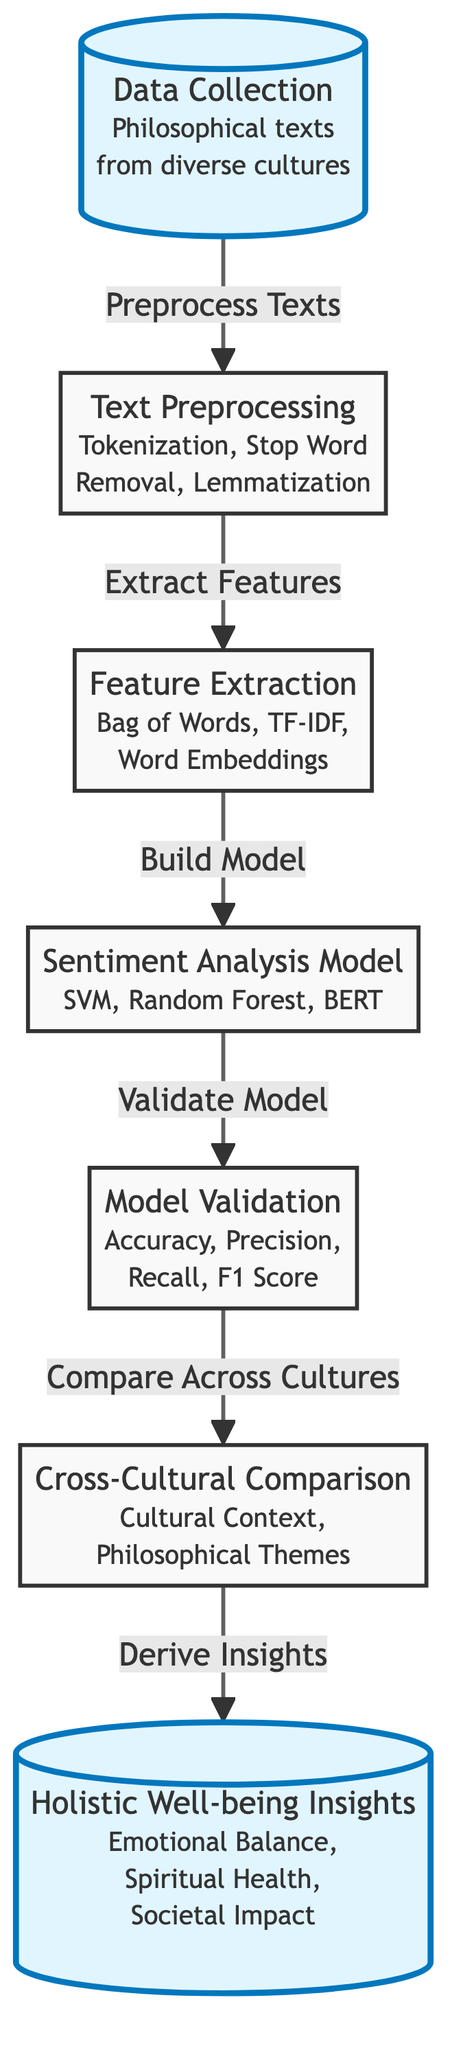What is the first step in the diagram? The diagram begins with the first step labeled "Data Collection" which involves collecting philosophical texts from diverse cultures.
Answer: Data Collection How many main process nodes are in the diagram? Counting the labeled nodes in the flowchart provides a total of seven main process nodes that represent key steps in the sentiment analysis framework.
Answer: Seven What type of models are mentioned for sentiment analysis? The sentiment analysis model section specifies several model types, including Support Vector Machine, Random Forest, and BERT.
Answer: SVM, Random Forest, BERT What is the output of the validation step? The validation step leads to the assessment of model quality using accuracy, precision, recall, and F1 score, indicating how effective the model is after it has been built.
Answer: Accuracy, Precision, Recall, F1 Score Which node describes deriving insights? The "Holistic Well-being Insights" node is where insights about emotional balance, spiritual health, and societal impact are derived from the analysis, representing the final goal of the process.
Answer: Holistic Well-being Insights In what step does feature extraction occur? The feature extraction occurs between the text preprocessing and model building steps, which specifically involves converting text data into formats usable by machine learning models.
Answer: Extract Features What is compared in the cross-cultural comparison step? This step involves a comparison that focuses on cultural context and philosophical themes, thereby evaluating how different cultures interpret messages in philosophical texts.
Answer: Cultural Context, Philosophical Themes What does the diagram suggest comes after model validation? After model validation is the cross-cultural comparison step, which indicates that validating the model is crucial before comparing sentiment across different cultures.
Answer: Compare Across Cultures What is the overall aim of the process represented in the last node? The final node aims to provide holistic well-being insights, implying that the sentiment analysis serves a broader purpose beyond merely understanding text.
Answer: Holistic Well-being Insights 